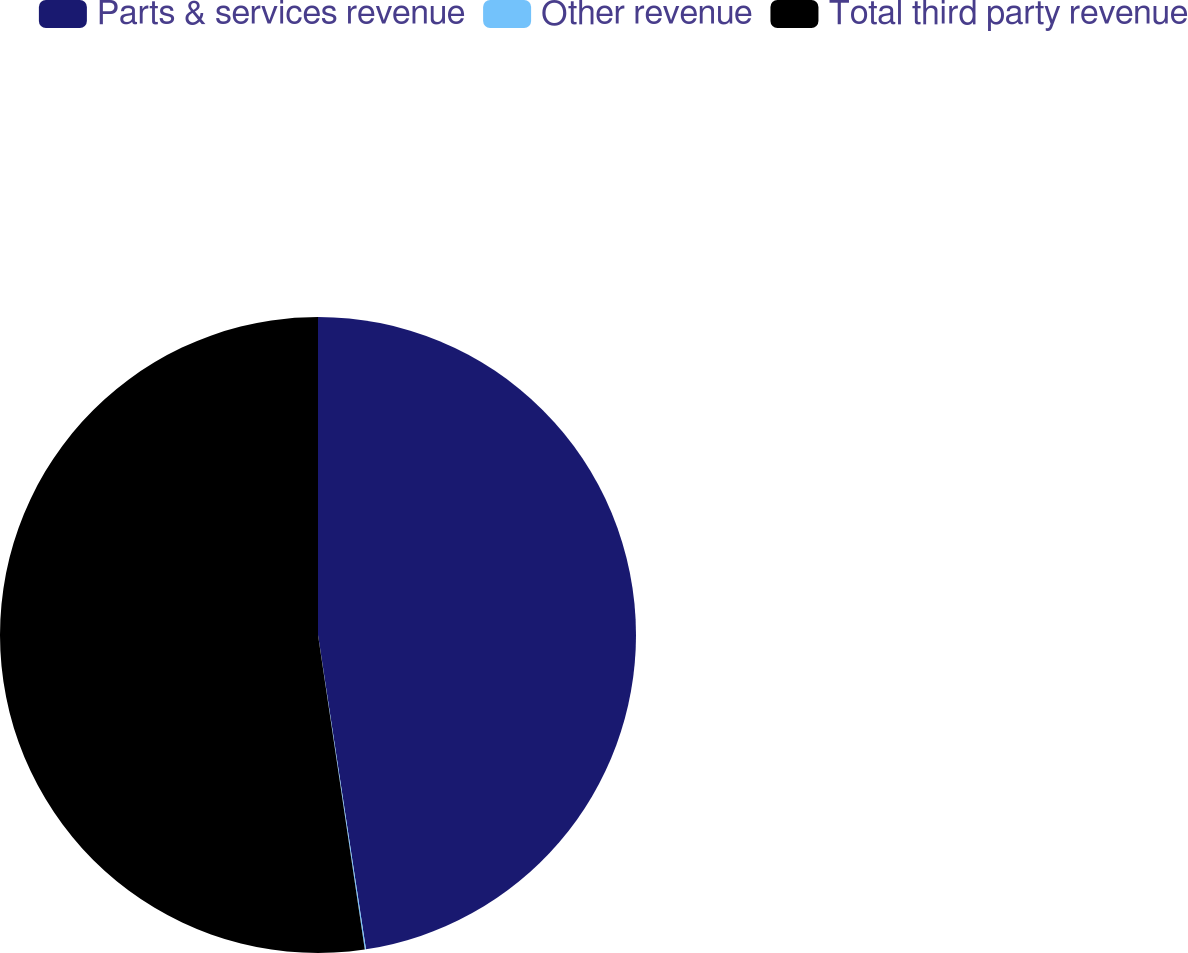<chart> <loc_0><loc_0><loc_500><loc_500><pie_chart><fcel>Parts & services revenue<fcel>Other revenue<fcel>Total third party revenue<nl><fcel>47.59%<fcel>0.06%<fcel>52.35%<nl></chart> 